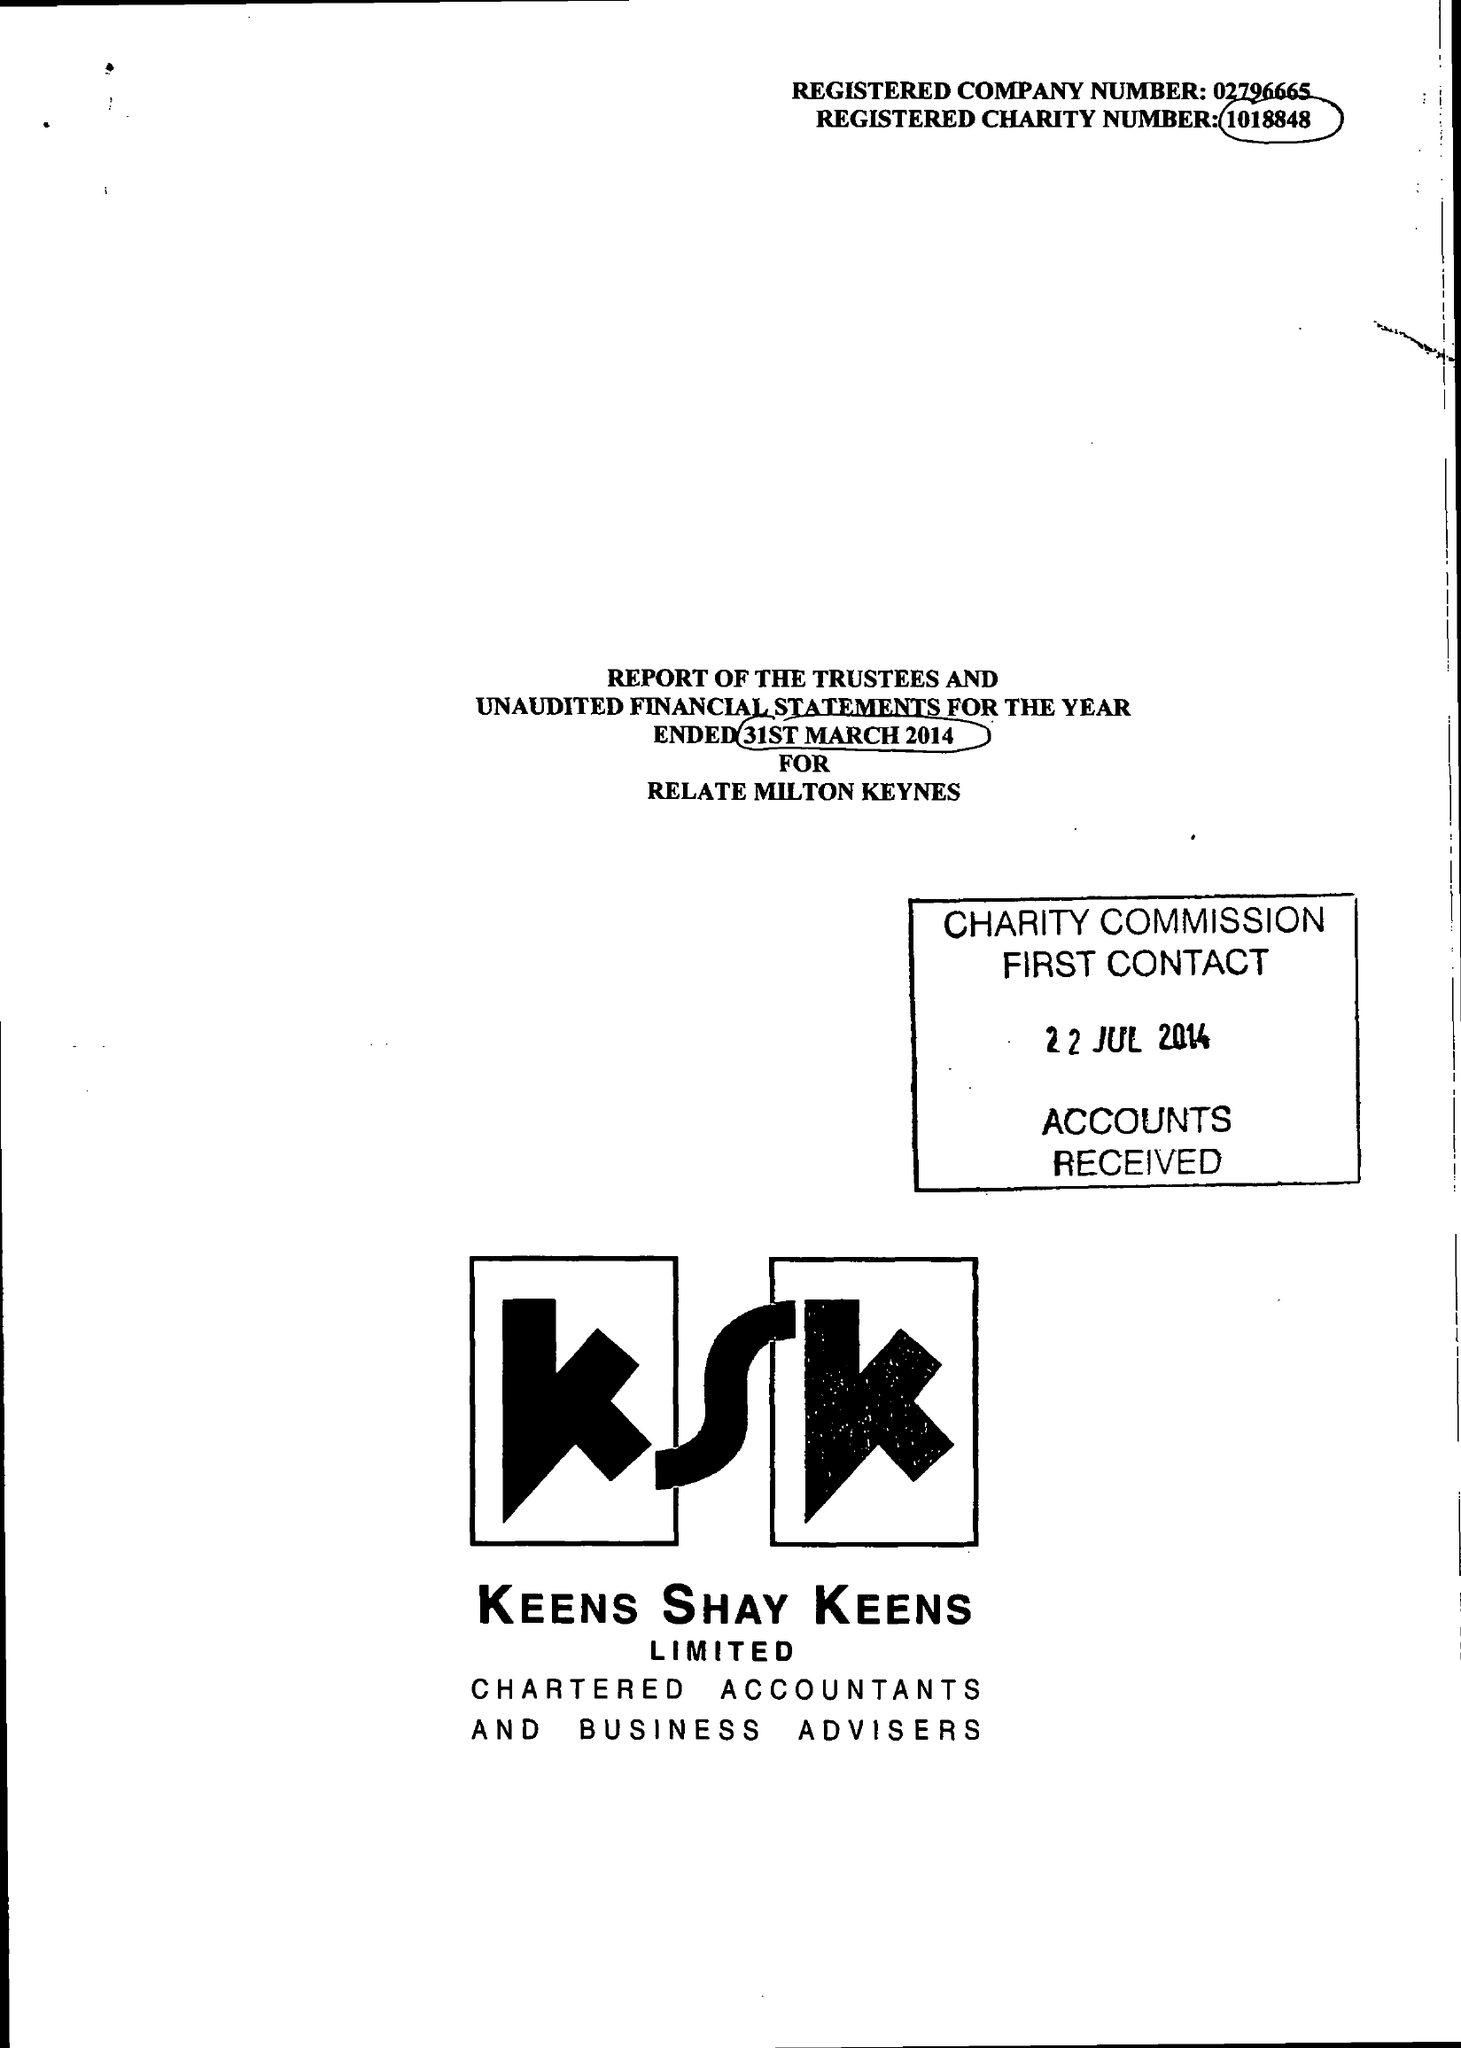What is the value for the address__post_town?
Answer the question using a single word or phrase. MILTON KEYNES 